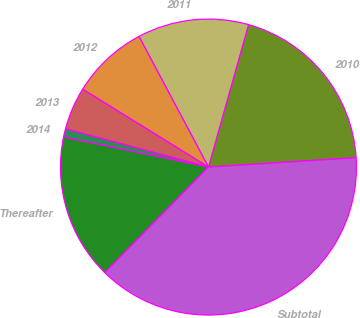Convert chart. <chart><loc_0><loc_0><loc_500><loc_500><pie_chart><fcel>2010<fcel>2011<fcel>2012<fcel>2013<fcel>2014<fcel>Thereafter<fcel>Subtotal<nl><fcel>19.63%<fcel>12.15%<fcel>8.4%<fcel>4.66%<fcel>0.91%<fcel>15.89%<fcel>38.36%<nl></chart> 